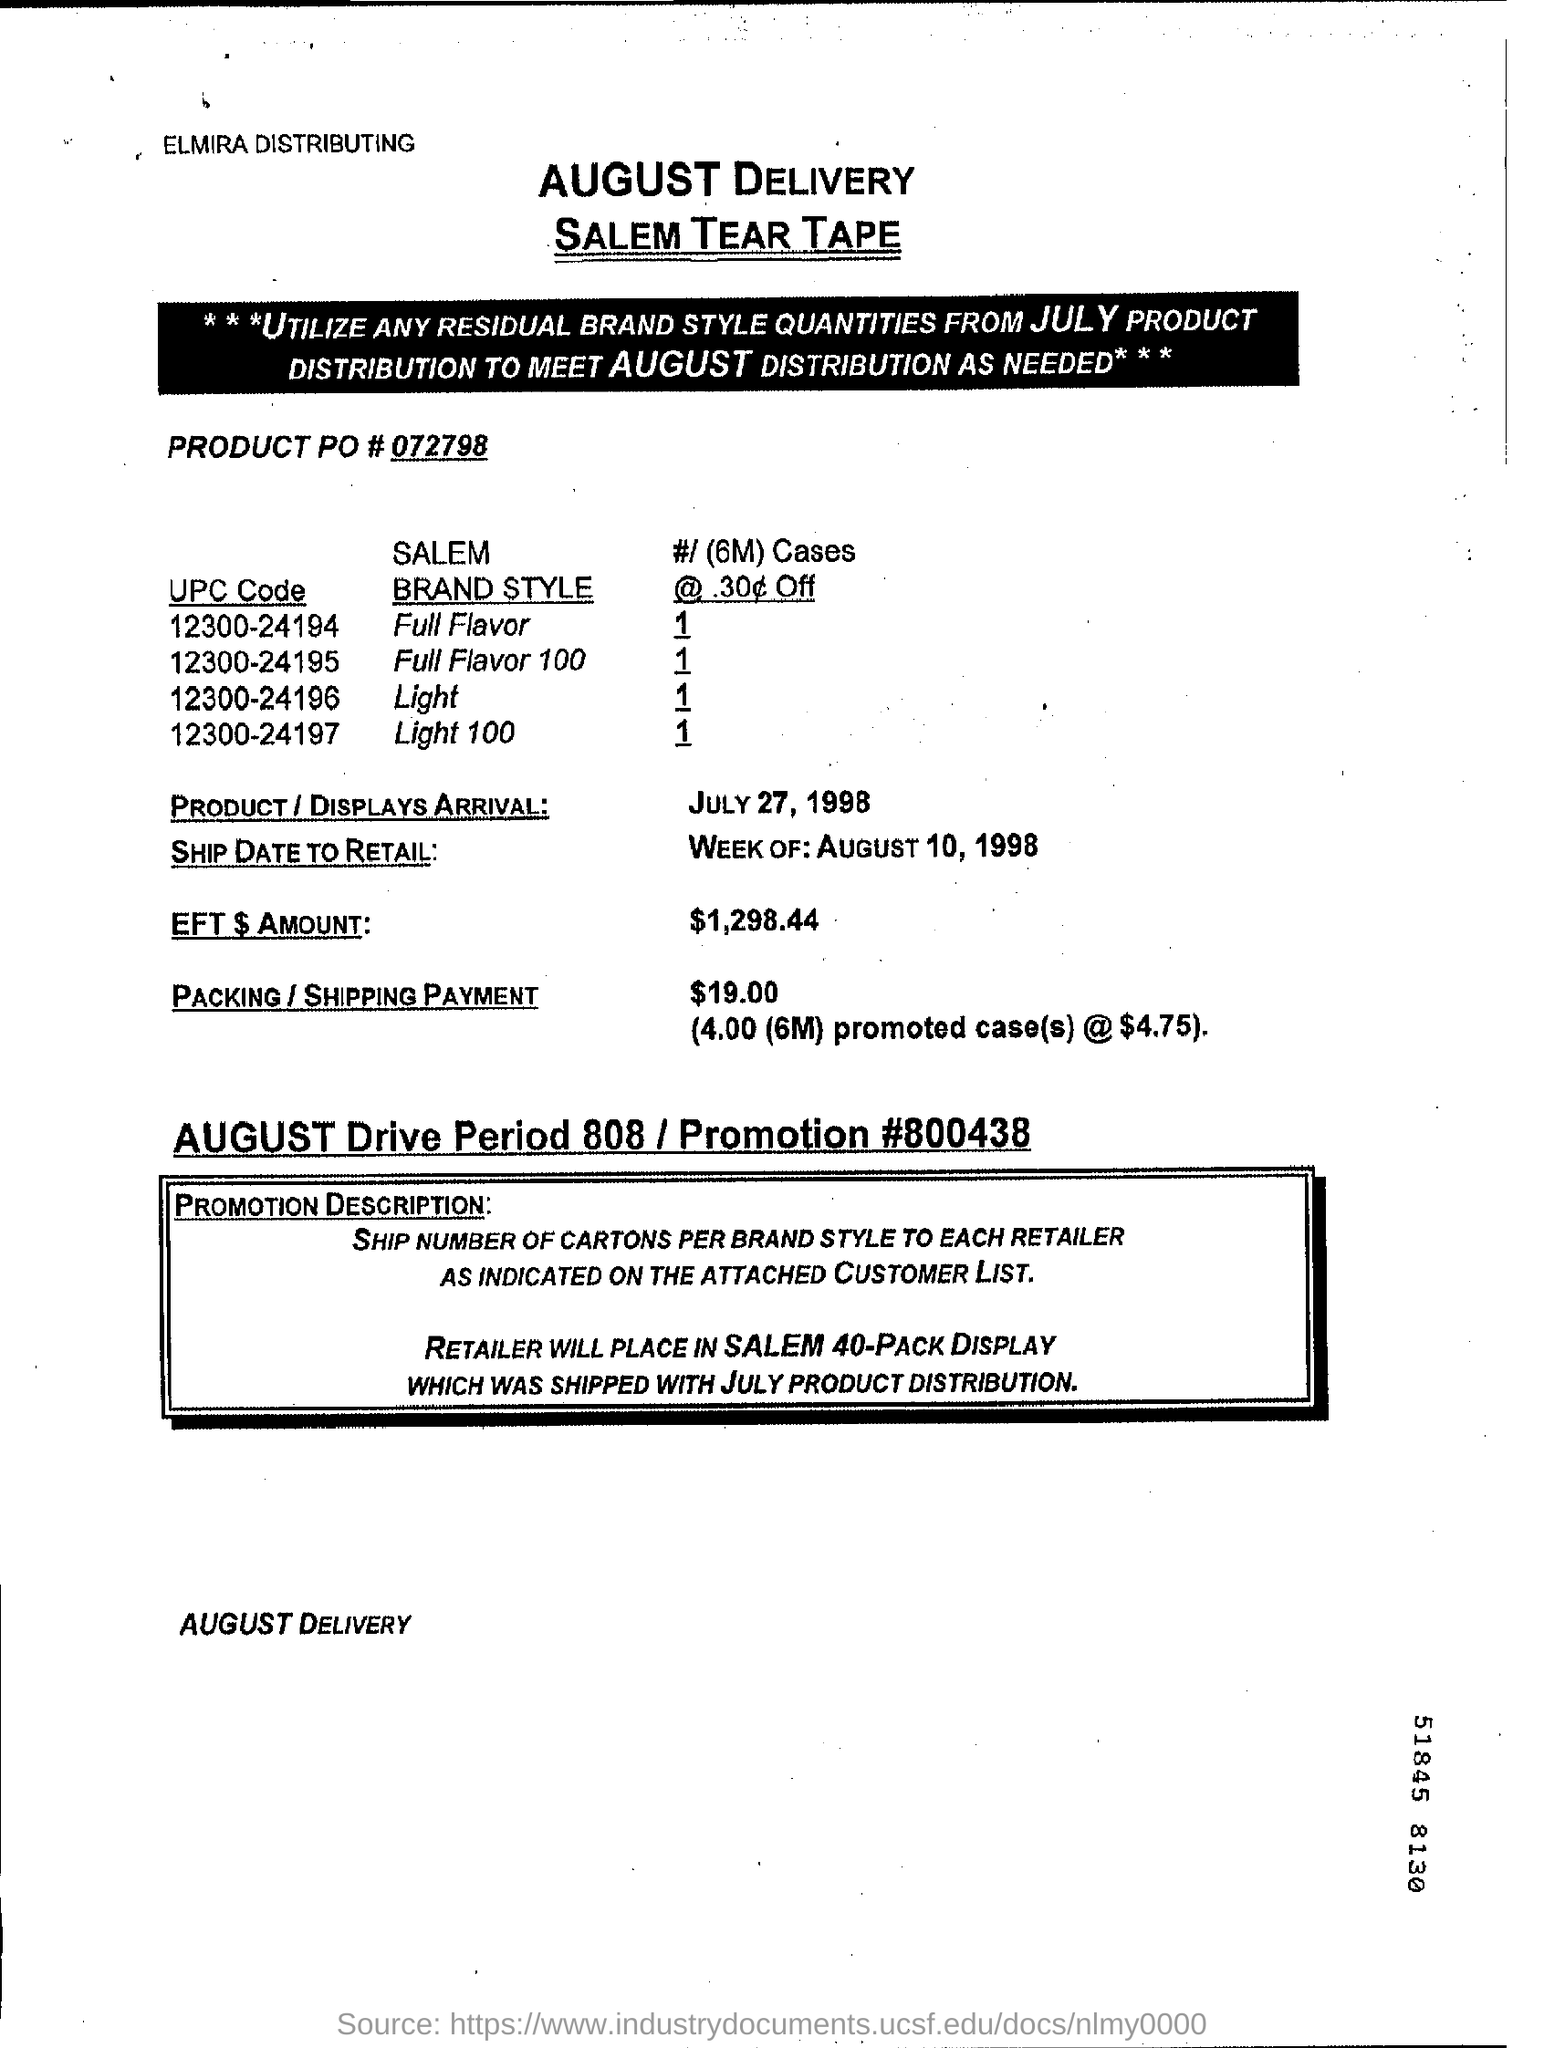What is product arrival date ?
Your answer should be very brief. JULY 27, 1998. What is the ship date to retail ?
Give a very brief answer. Week of: august 10, 1998. What are the charges of packing / shipping?
Your answer should be very brief. $19.00. What is the product po number?
Make the answer very short. 072798. 